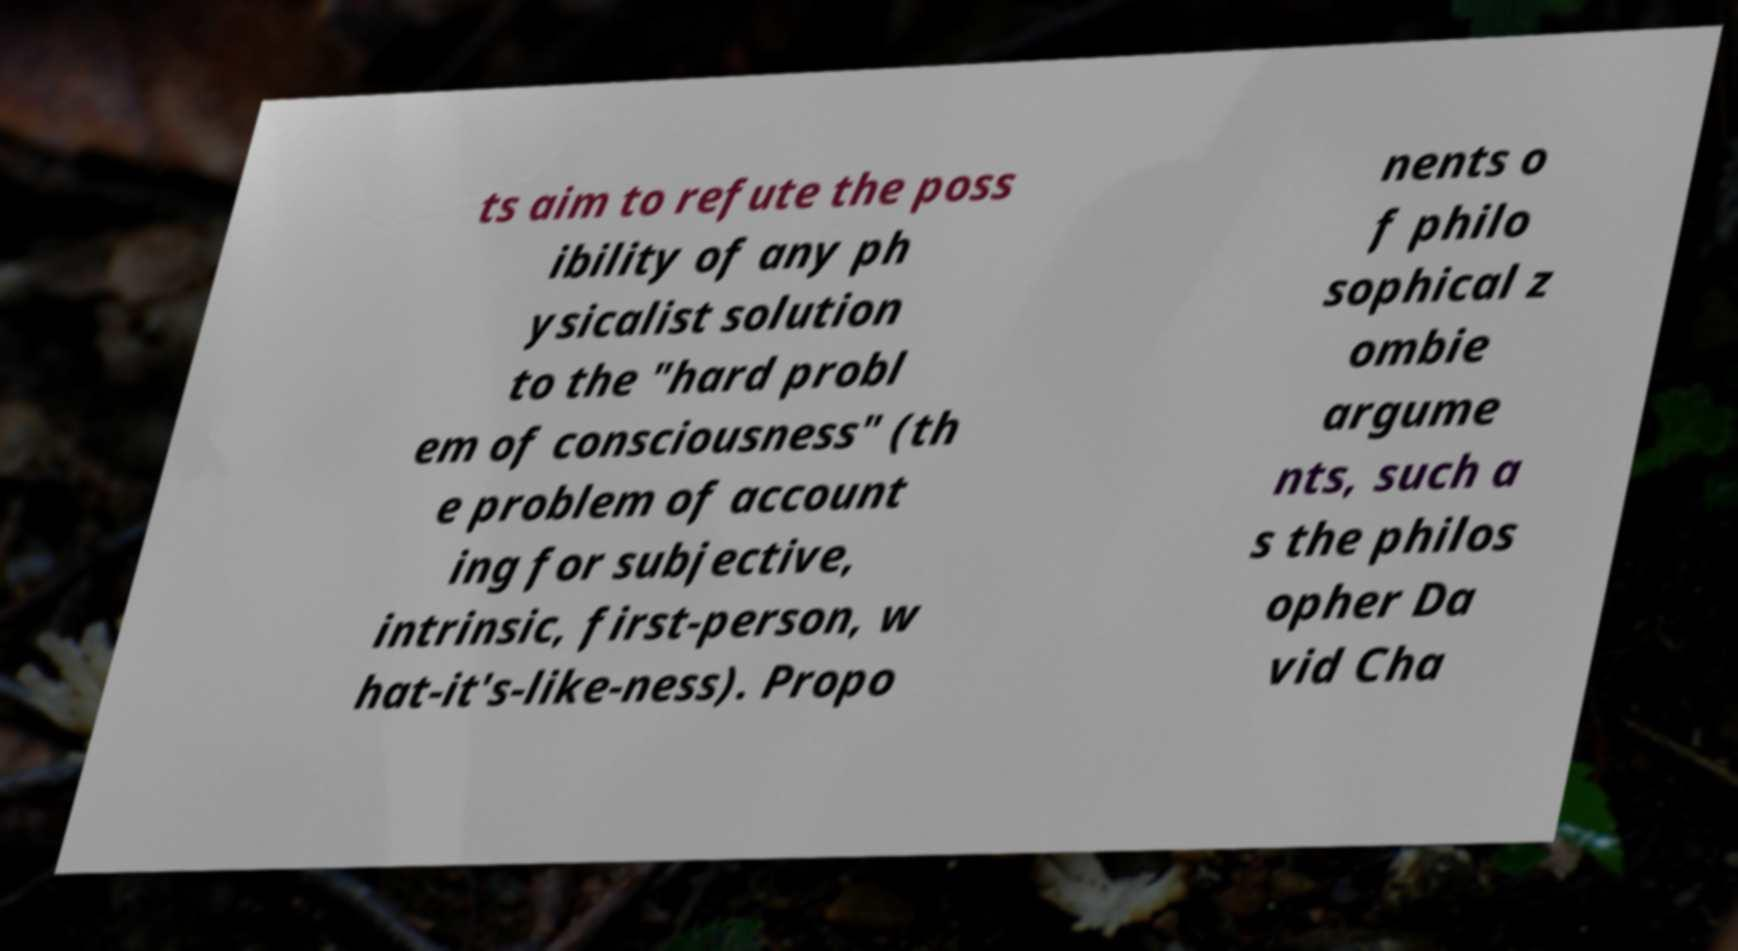Please read and relay the text visible in this image. What does it say? ts aim to refute the poss ibility of any ph ysicalist solution to the "hard probl em of consciousness" (th e problem of account ing for subjective, intrinsic, first-person, w hat-it's-like-ness). Propo nents o f philo sophical z ombie argume nts, such a s the philos opher Da vid Cha 